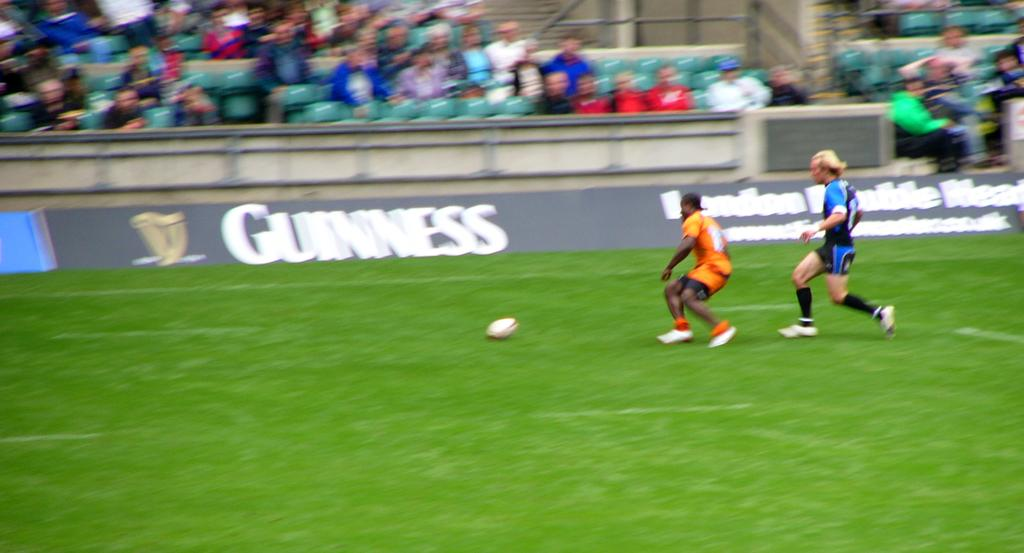<image>
Describe the image concisely. Two soccer players on the field in front of a Guinness ad. 